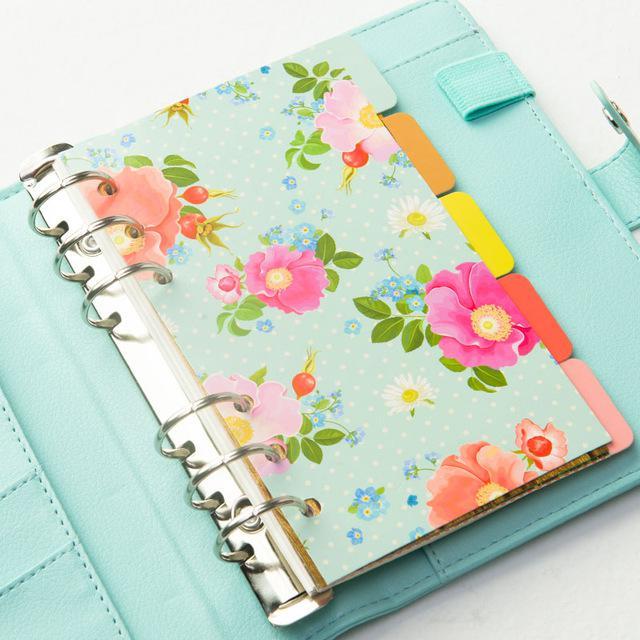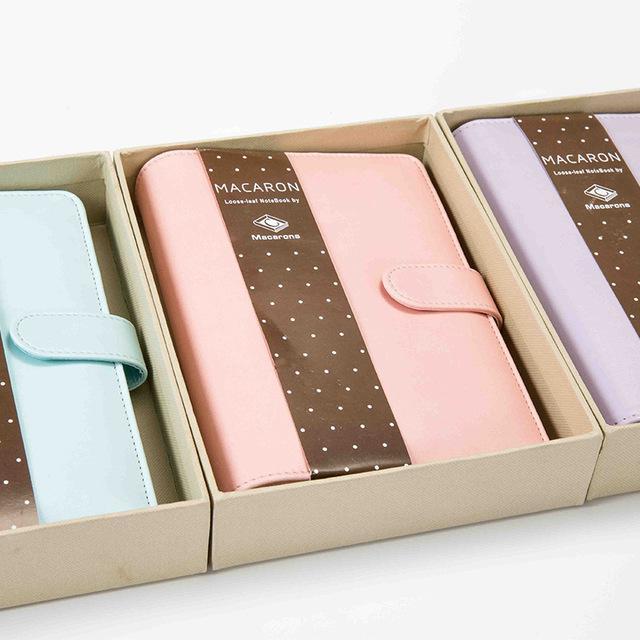The first image is the image on the left, the second image is the image on the right. Evaluate the accuracy of this statement regarding the images: "One of the binders is gold.". Is it true? Answer yes or no. No. 